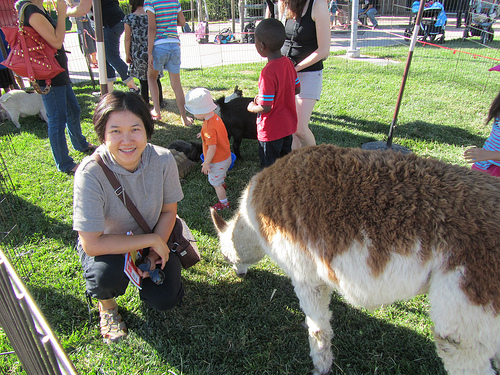Please provide the bounding box coordinate of the region this sentence describes: Brown bag woman is carrying. The bounding box coordinates for the brown bag the woman is carrying are [0.17, 0.41, 0.41, 0.67]. 